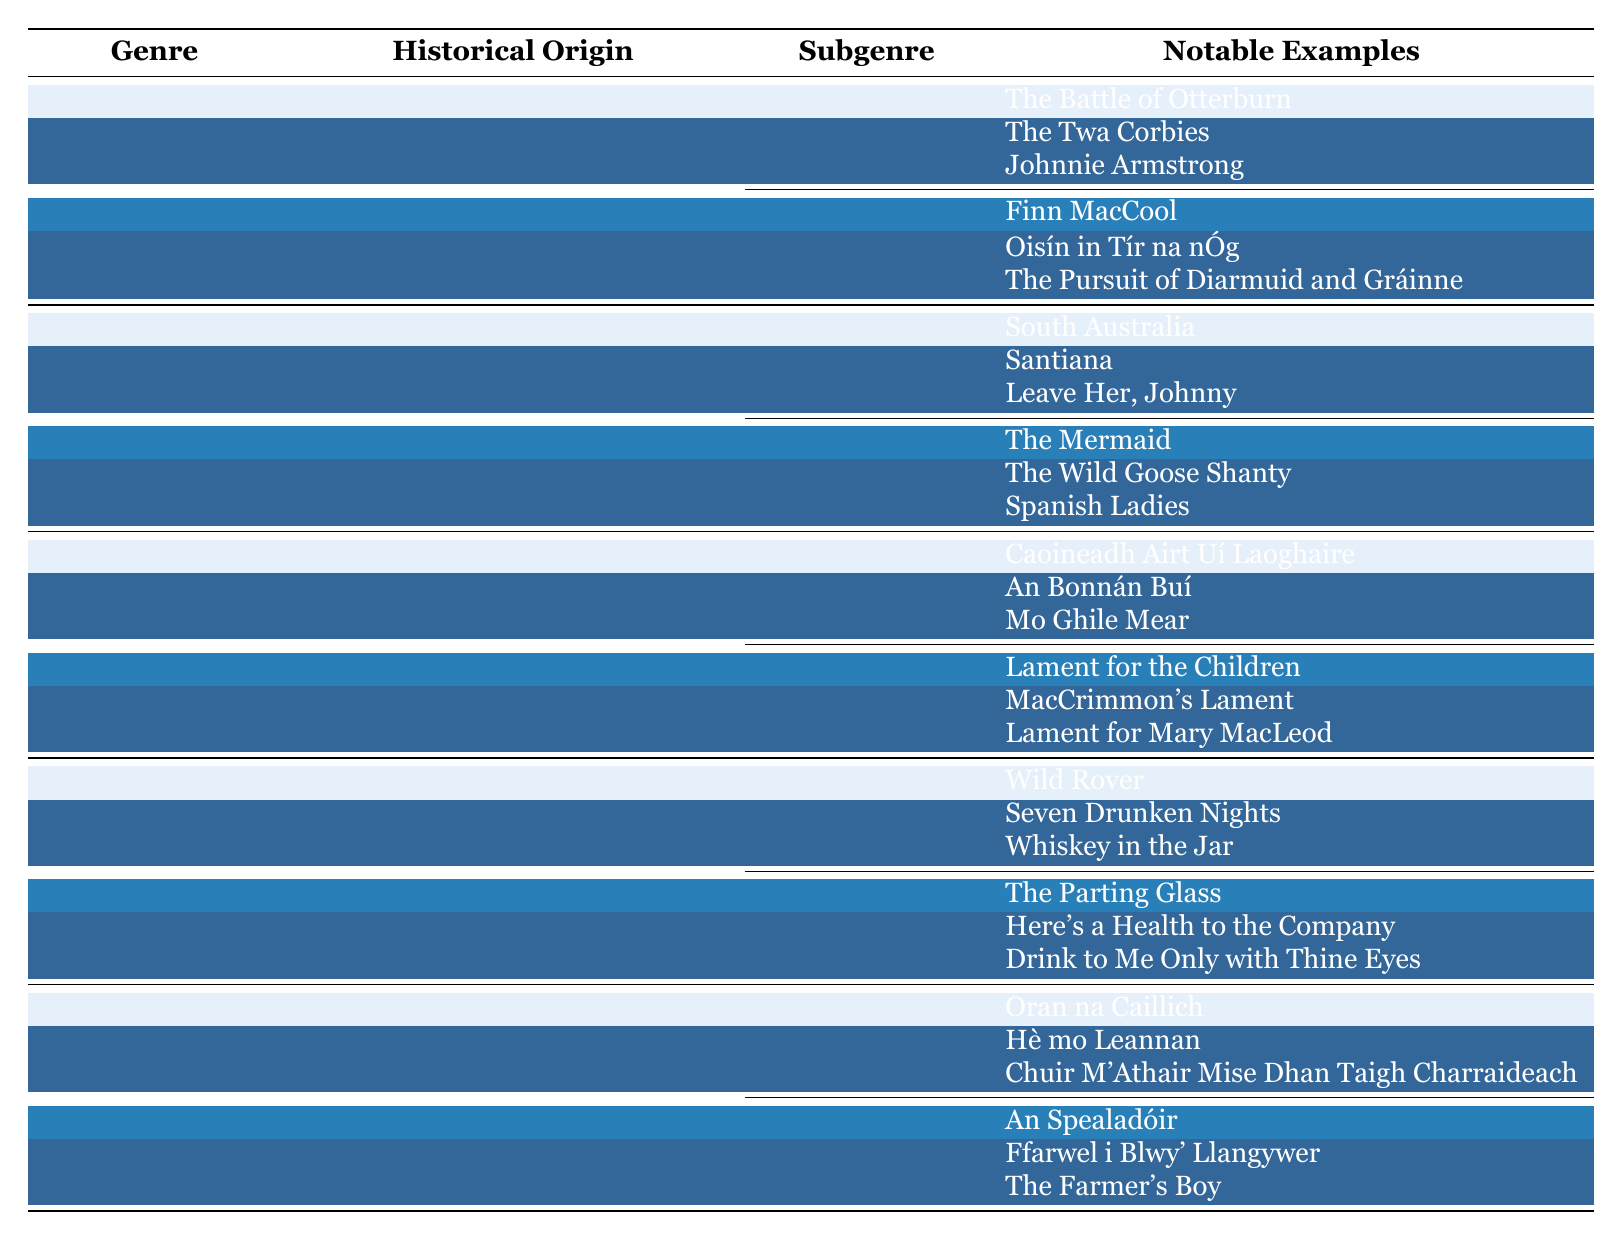What are the notable examples of Ballads? In the table, under the Ballads genre, the notable examples listed are The Battle of Otterburn, The Twa Corbies, and Johnnie Armstrong.
Answer: The Battle of Otterburn, The Twa Corbies, Johnnie Armstrong What historical origin is associated with Sea Shanties? The table specifies that Sea Shanties have their historical origin in the 18th-19th century maritime culture.
Answer: 18th-19th century maritime culture How many subgenres are there under Drinking Songs? According to the table, there are two subgenres listed under Drinking Songs: Tavern Songs and Toast Songs.
Answer: 2 Are there any notable examples listed under Piobaireachd? Yes, the table mentions notable examples of Piobaireachd, which are Lament for the Children, MacCrimmon's Lament, and Lament for Mary MacLeod.
Answer: Yes Which genre originates from ancient Gaelic tradition? The Laments genre is noted in the table as having its historical origin in Ancient Gaelic tradition.
Answer: Laments Do both subgenres of Work Songs originate from the same region? No, the table indicates that Waulking Songs originate from Scotland, while Plough Songs originate from Ireland and Wales.
Answer: No Which genre has notable examples including "Finn MacCool"? The genre that includes "Finn MacCool" among its notable examples is Fenian Ballads, which is a subgenre of Ballads.
Answer: Ballads What is the purpose of Capstan Shanties? The table states that the purpose of Capstan Shanties is to raise anchor.
Answer: Raising anchor What is the total number of notable examples for Tavern Songs? The table provides three notable examples for Tavern Songs: Wild Rover, Seven Drunken Nights, and Whiskey in the Jar. So the total is 3.
Answer: 3 Which genre includes work songs related to farming? The Plough Songs subgenre found under Work Songs includes work songs related to farming.
Answer: Work Songs 